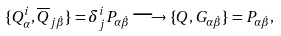Convert formula to latex. <formula><loc_0><loc_0><loc_500><loc_500>\{ Q ^ { i } _ { \alpha } , \overline { Q } _ { j \dot { \beta } } \} = \delta ^ { i } _ { j } P _ { \alpha \dot { \beta } } \longrightarrow \{ Q , G _ { \alpha \dot { \beta } } \} = P _ { \alpha \dot { \beta } } ,</formula> 